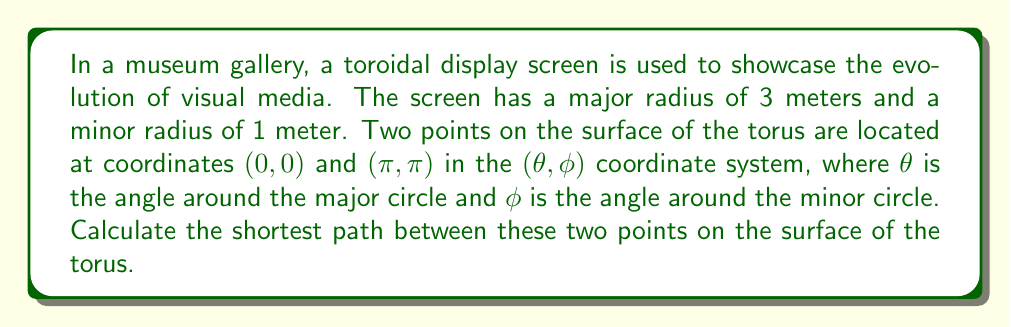Can you answer this question? To solve this problem, we'll follow these steps:

1) The formula for the geodesic distance on a torus between two points $(\theta_1, \phi_1)$ and $(\theta_2, \phi_2)$ is:

   $$d = \sqrt{(R\Delta\theta)^2 + (r\Delta\phi)^2 - 2Rr\Delta\theta\Delta\phi\cos\gamma}$$

   where $R$ is the major radius, $r$ is the minor radius, $\Delta\theta = \theta_2 - \theta_1$, $\Delta\phi = \phi_2 - \phi_1$, and $\gamma = \arctan(\frac{r}{R})$.

2) In our case:
   $R = 3$ meters
   $r = 1$ meter
   $(\theta_1, \phi_1) = (0, 0)$
   $(\theta_2, \phi_2) = (\pi, \pi)$

3) Calculate $\Delta\theta$ and $\Delta\phi$:
   $\Delta\theta = \pi - 0 = \pi$
   $\Delta\phi = \pi - 0 = \pi$

4) Calculate $\gamma$:
   $$\gamma = \arctan(\frac{r}{R}) = \arctan(\frac{1}{3}) \approx 0.3218$$

5) Now we can substitute these values into our distance formula:

   $$\begin{align}
   d &= \sqrt{(3\pi)^2 + (1\pi)^2 - 2(3)(1)\pi\pi\cos(0.3218)} \\
   &= \sqrt{9\pi^2 + \pi^2 - 6\pi^2\cos(0.3218)} \\
   &= \sqrt{10\pi^2 - 6\pi^2(0.9486)} \\
   &= \sqrt{10\pi^2 - 5.6916\pi^2} \\
   &= \sqrt{4.3084\pi^2} \\
   &= \pi\sqrt{4.3084} \\
   &\approx 6.5047
   \end{align}$$

Therefore, the shortest path between the two points on the toroidal display is approximately 6.5047 meters.
Answer: $6.5047$ meters 